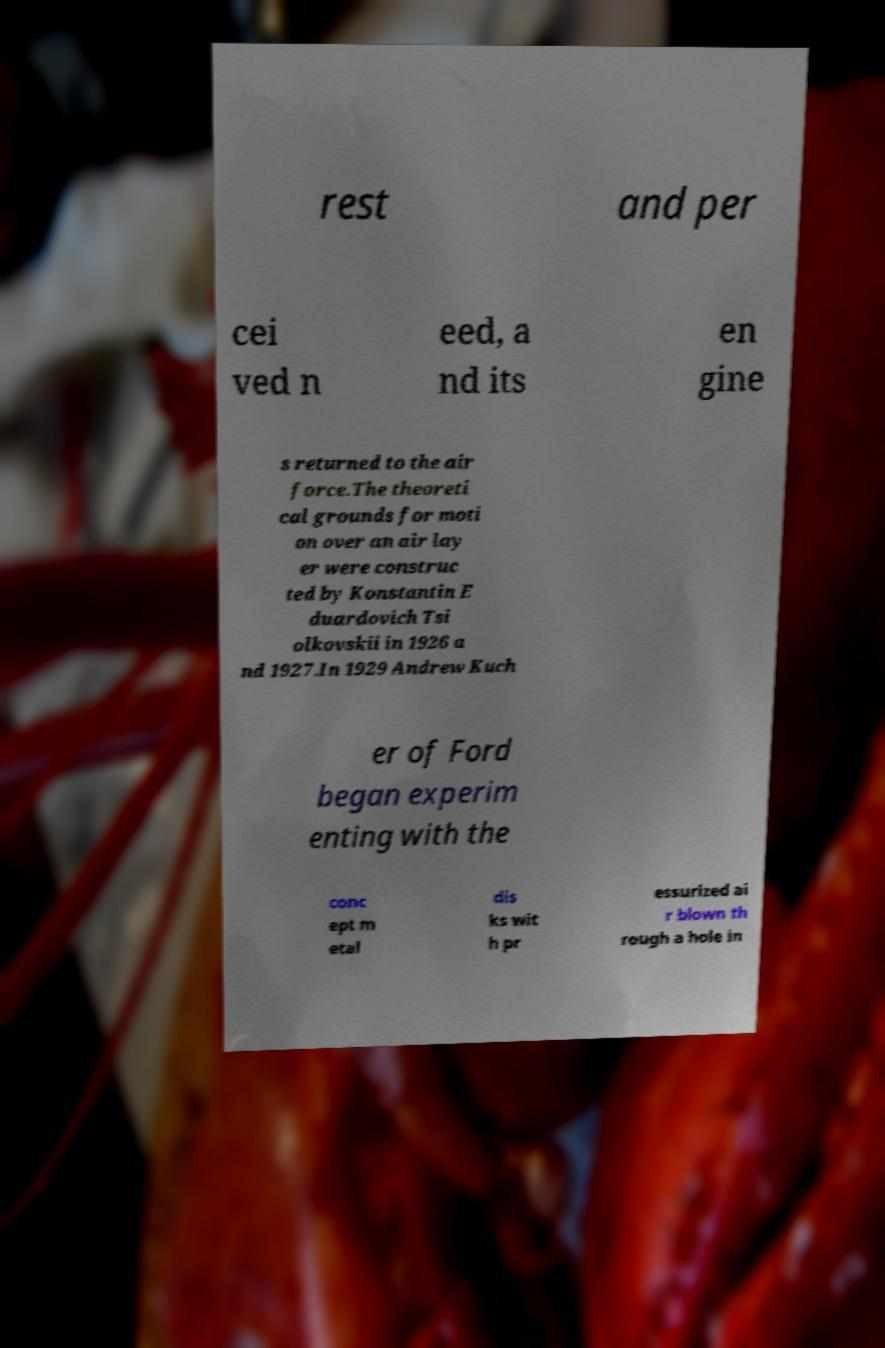Could you assist in decoding the text presented in this image and type it out clearly? rest and per cei ved n eed, a nd its en gine s returned to the air force.The theoreti cal grounds for moti on over an air lay er were construc ted by Konstantin E duardovich Tsi olkovskii in 1926 a nd 1927.In 1929 Andrew Kuch er of Ford began experim enting with the conc ept m etal dis ks wit h pr essurized ai r blown th rough a hole in 